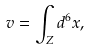Convert formula to latex. <formula><loc_0><loc_0><loc_500><loc_500>v = \int _ { Z } d ^ { 6 } x ,</formula> 